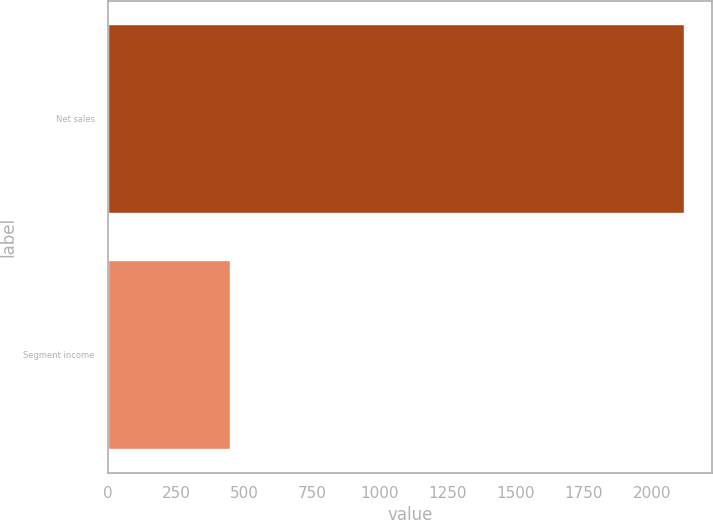Convert chart to OTSL. <chart><loc_0><loc_0><loc_500><loc_500><bar_chart><fcel>Net sales<fcel>Segment income<nl><fcel>2116<fcel>447.2<nl></chart> 